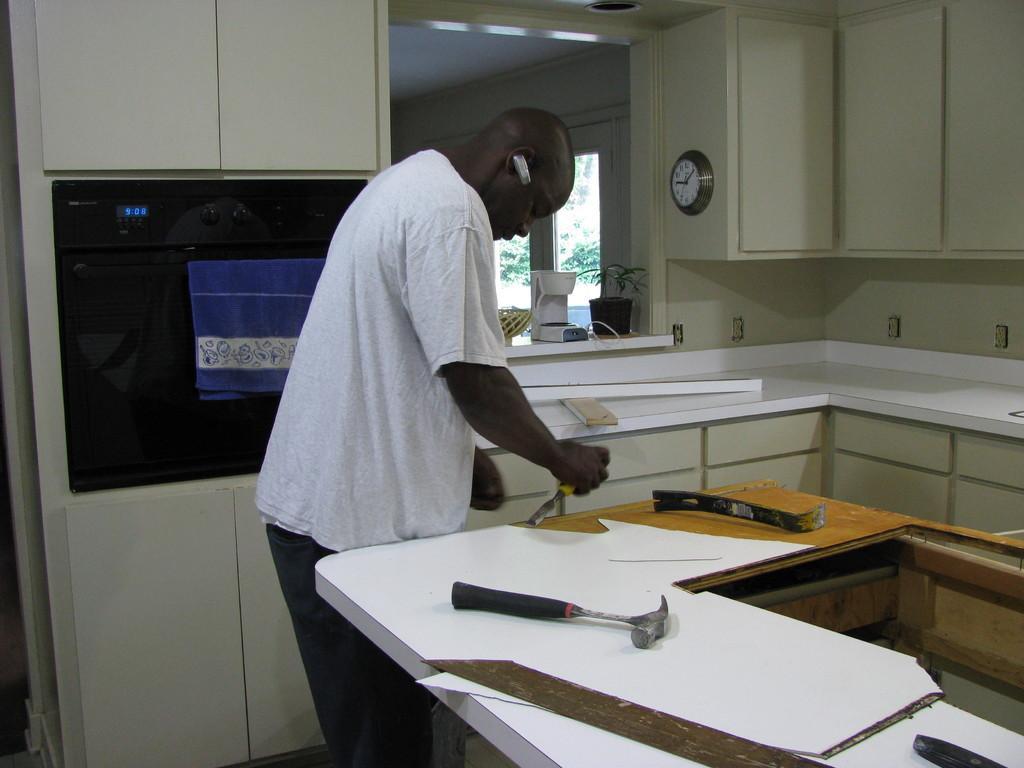How would you summarize this image in a sentence or two? In this picture,there is a man who is wearing microphone on his ear and he is catching a weapon in his hand. There is a table and and a hammer is present on the table. There is a wall clock on the wall. There is a flower pot on the table. On to the left, there is a machine and a cloth is visible on the machine, which is a reflection of the cloth. At the background there is a tree. 